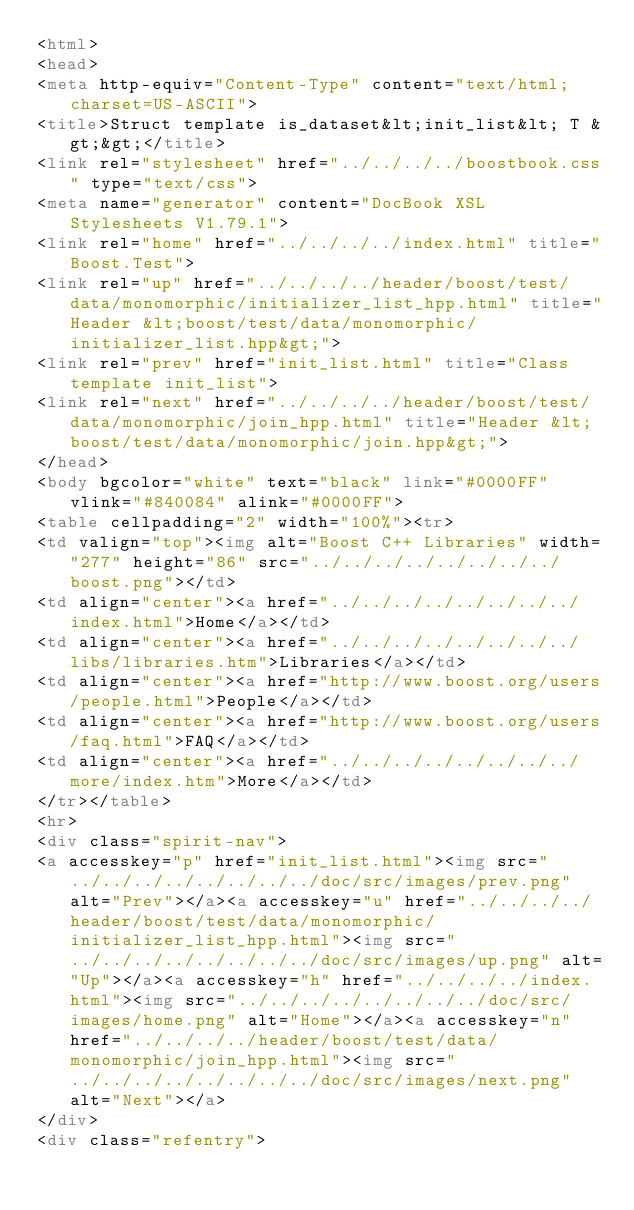<code> <loc_0><loc_0><loc_500><loc_500><_HTML_><html>
<head>
<meta http-equiv="Content-Type" content="text/html; charset=US-ASCII">
<title>Struct template is_dataset&lt;init_list&lt; T &gt;&gt;</title>
<link rel="stylesheet" href="../../../../boostbook.css" type="text/css">
<meta name="generator" content="DocBook XSL Stylesheets V1.79.1">
<link rel="home" href="../../../../index.html" title="Boost.Test">
<link rel="up" href="../../../../header/boost/test/data/monomorphic/initializer_list_hpp.html" title="Header &lt;boost/test/data/monomorphic/initializer_list.hpp&gt;">
<link rel="prev" href="init_list.html" title="Class template init_list">
<link rel="next" href="../../../../header/boost/test/data/monomorphic/join_hpp.html" title="Header &lt;boost/test/data/monomorphic/join.hpp&gt;">
</head>
<body bgcolor="white" text="black" link="#0000FF" vlink="#840084" alink="#0000FF">
<table cellpadding="2" width="100%"><tr>
<td valign="top"><img alt="Boost C++ Libraries" width="277" height="86" src="../../../../../../../../boost.png"></td>
<td align="center"><a href="../../../../../../../../index.html">Home</a></td>
<td align="center"><a href="../../../../../../../../libs/libraries.htm">Libraries</a></td>
<td align="center"><a href="http://www.boost.org/users/people.html">People</a></td>
<td align="center"><a href="http://www.boost.org/users/faq.html">FAQ</a></td>
<td align="center"><a href="../../../../../../../../more/index.htm">More</a></td>
</tr></table>
<hr>
<div class="spirit-nav">
<a accesskey="p" href="init_list.html"><img src="../../../../../../../../doc/src/images/prev.png" alt="Prev"></a><a accesskey="u" href="../../../../header/boost/test/data/monomorphic/initializer_list_hpp.html"><img src="../../../../../../../../doc/src/images/up.png" alt="Up"></a><a accesskey="h" href="../../../../index.html"><img src="../../../../../../../../doc/src/images/home.png" alt="Home"></a><a accesskey="n" href="../../../../header/boost/test/data/monomorphic/join_hpp.html"><img src="../../../../../../../../doc/src/images/next.png" alt="Next"></a>
</div>
<div class="refentry"></code> 